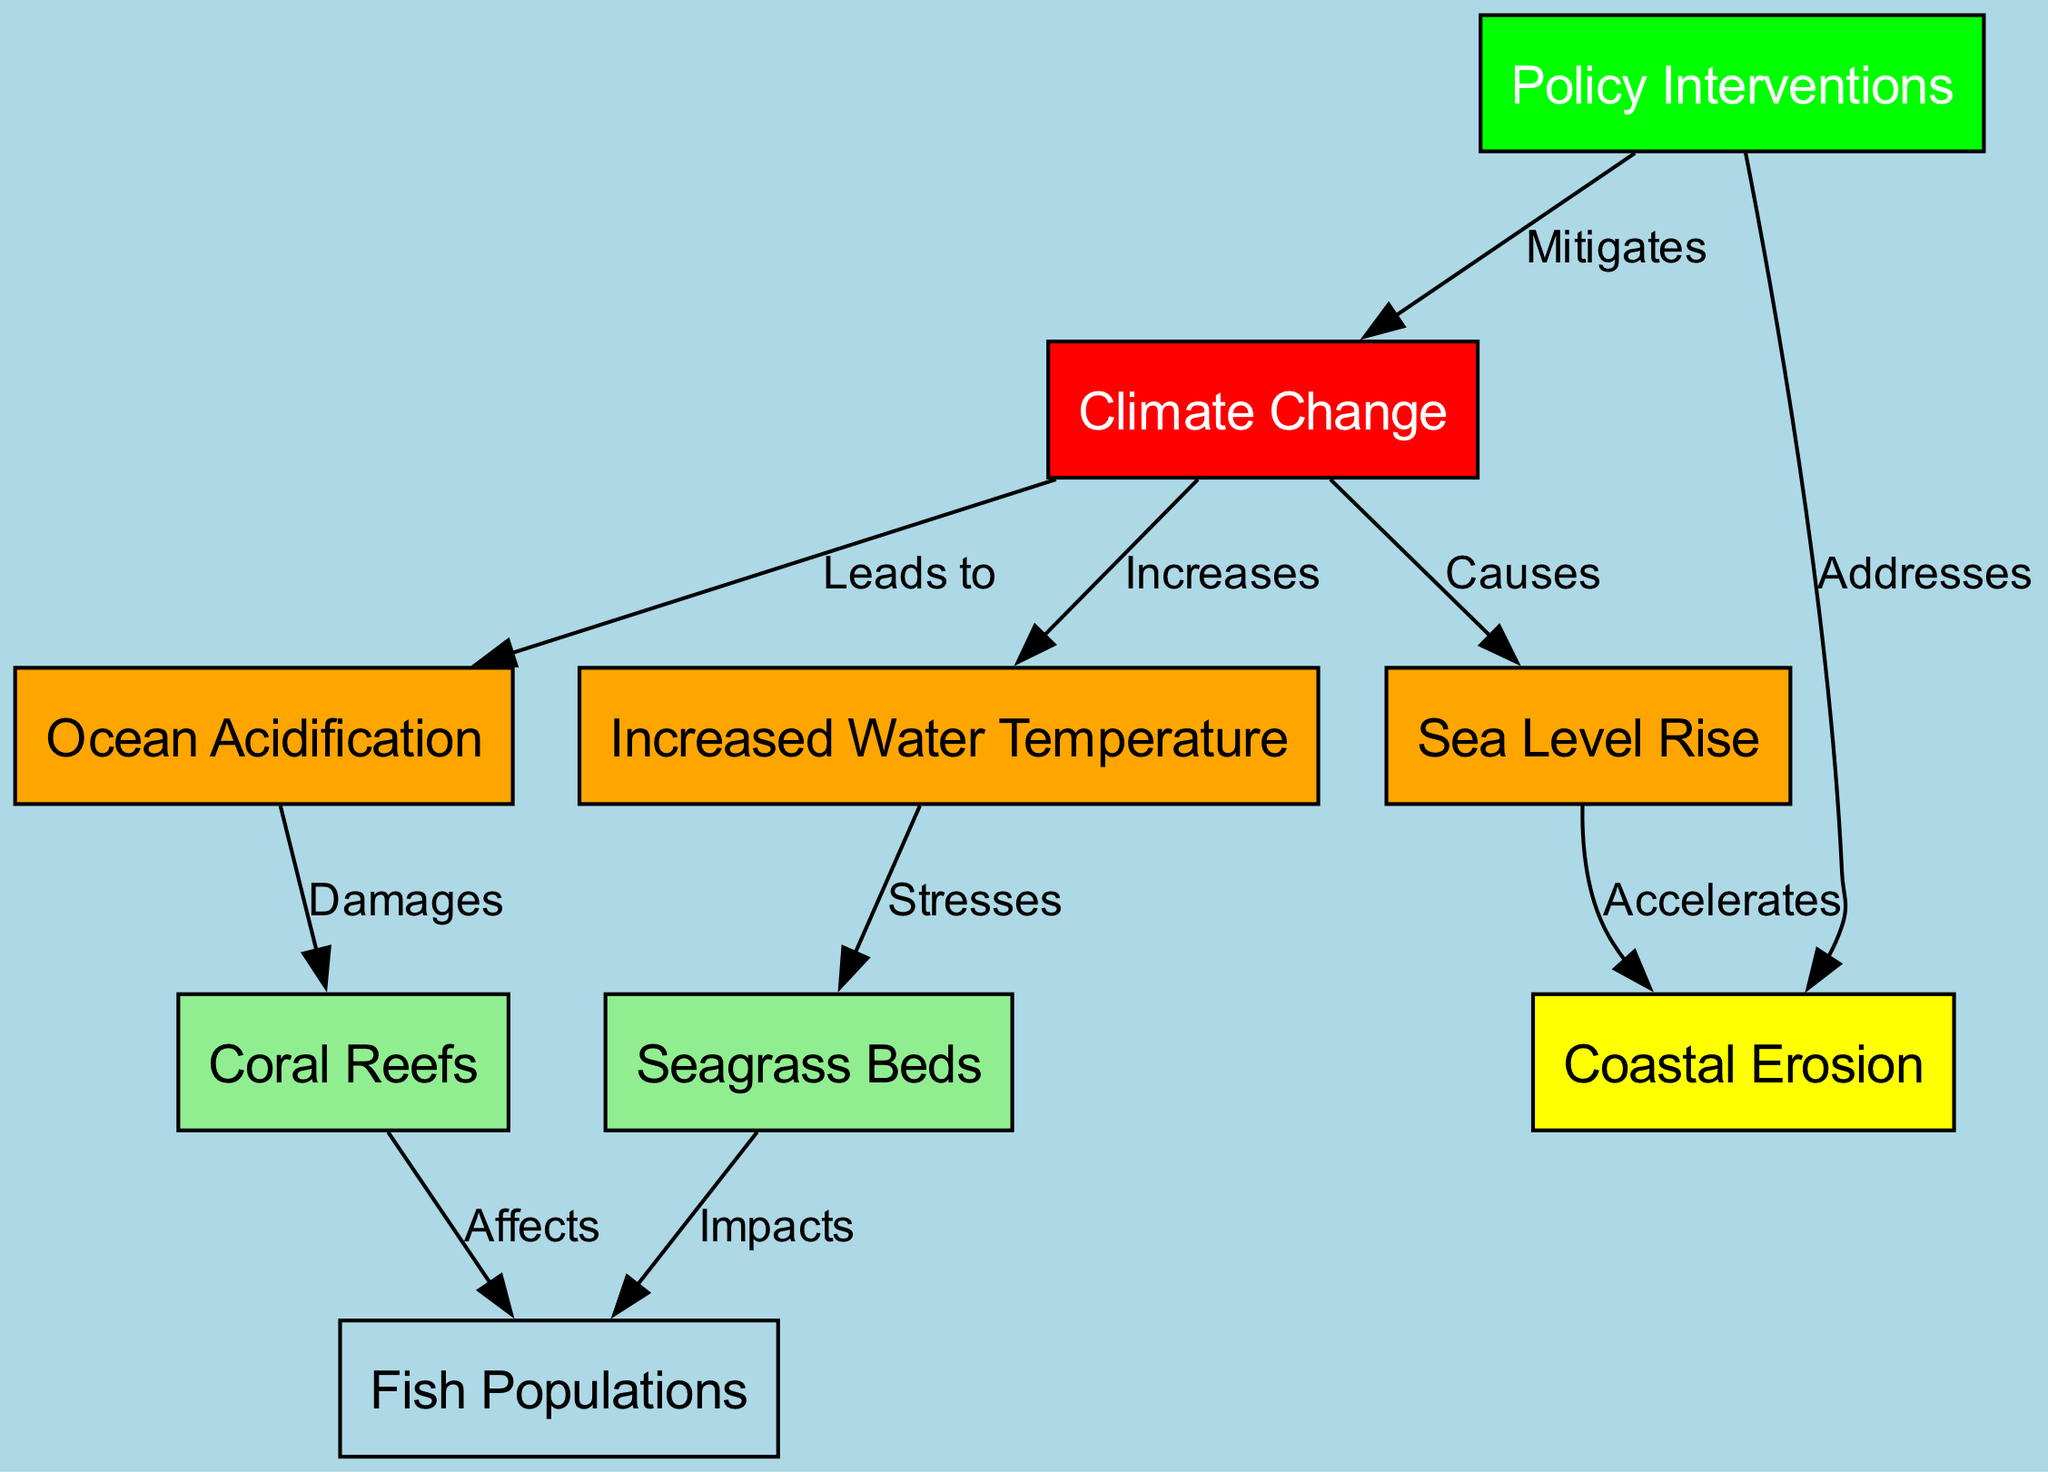What is the main factor causing changes in the ecosystem? The diagram indicates that "Climate Change" is the central node affecting various elements of the ecosystem, suggesting it is the primary factor in this context.
Answer: Climate Change How many nodes are present in the diagram? By counting the distinct entities labeled in the diagram, there are a total of 9 nodes shown, each representing a specific aspect of the ecosystem dynamics.
Answer: 9 What relationship exists between sea level rise and coastal erosion? The diagram illustrates that "Sea Level Rise" accelerates "Coastal Erosion," indicating a direct impact where one increases the severity of the other.
Answer: Accelerates Which node is affected by ocean acidification? According to the diagram, "Coral Reefs" are directly damaged by "Ocean Acidification," demonstrating a harmful effect of this environmental change on marine habitats.
Answer: Damages What do policy interventions mitigate? The diagram clearly states that "Policy Interventions" mitigate the impact of "Climate Change," highlighting an effort to address this root cause through regulatory or proactive measures.
Answer: Mitigates How does increased water temperature affect seagrass beds? The diagram notes that "Increased Water Temperature" stresses "Seagrass Beds," which suggests that rising temperatures are detrimental to these essential marine plants.
Answer: Stresses How many edges are there in the diagram? By evaluating the connections between the various nodes, there are 10 edges delineating the relationships and impacts among the ecosystem elements illustrated in the diagram.
Answer: 10 Which nodes are directly connected to fish populations? The diagram shows that both "Coral Reefs" and "Seagrass Beds" directly affect "Fish Populations," revealing that the health of these habitats is crucial for sustaining fish diversity.
Answer: Coral Reefs, Seagrass Beds What does ocean acidification lead to? The diagram specifies that "Ocean Acidification" leads to damage of "Coral Reefs," establishing a clear causal link that highlights the detrimental effects of acidification on vital marine structures.
Answer: Damages 